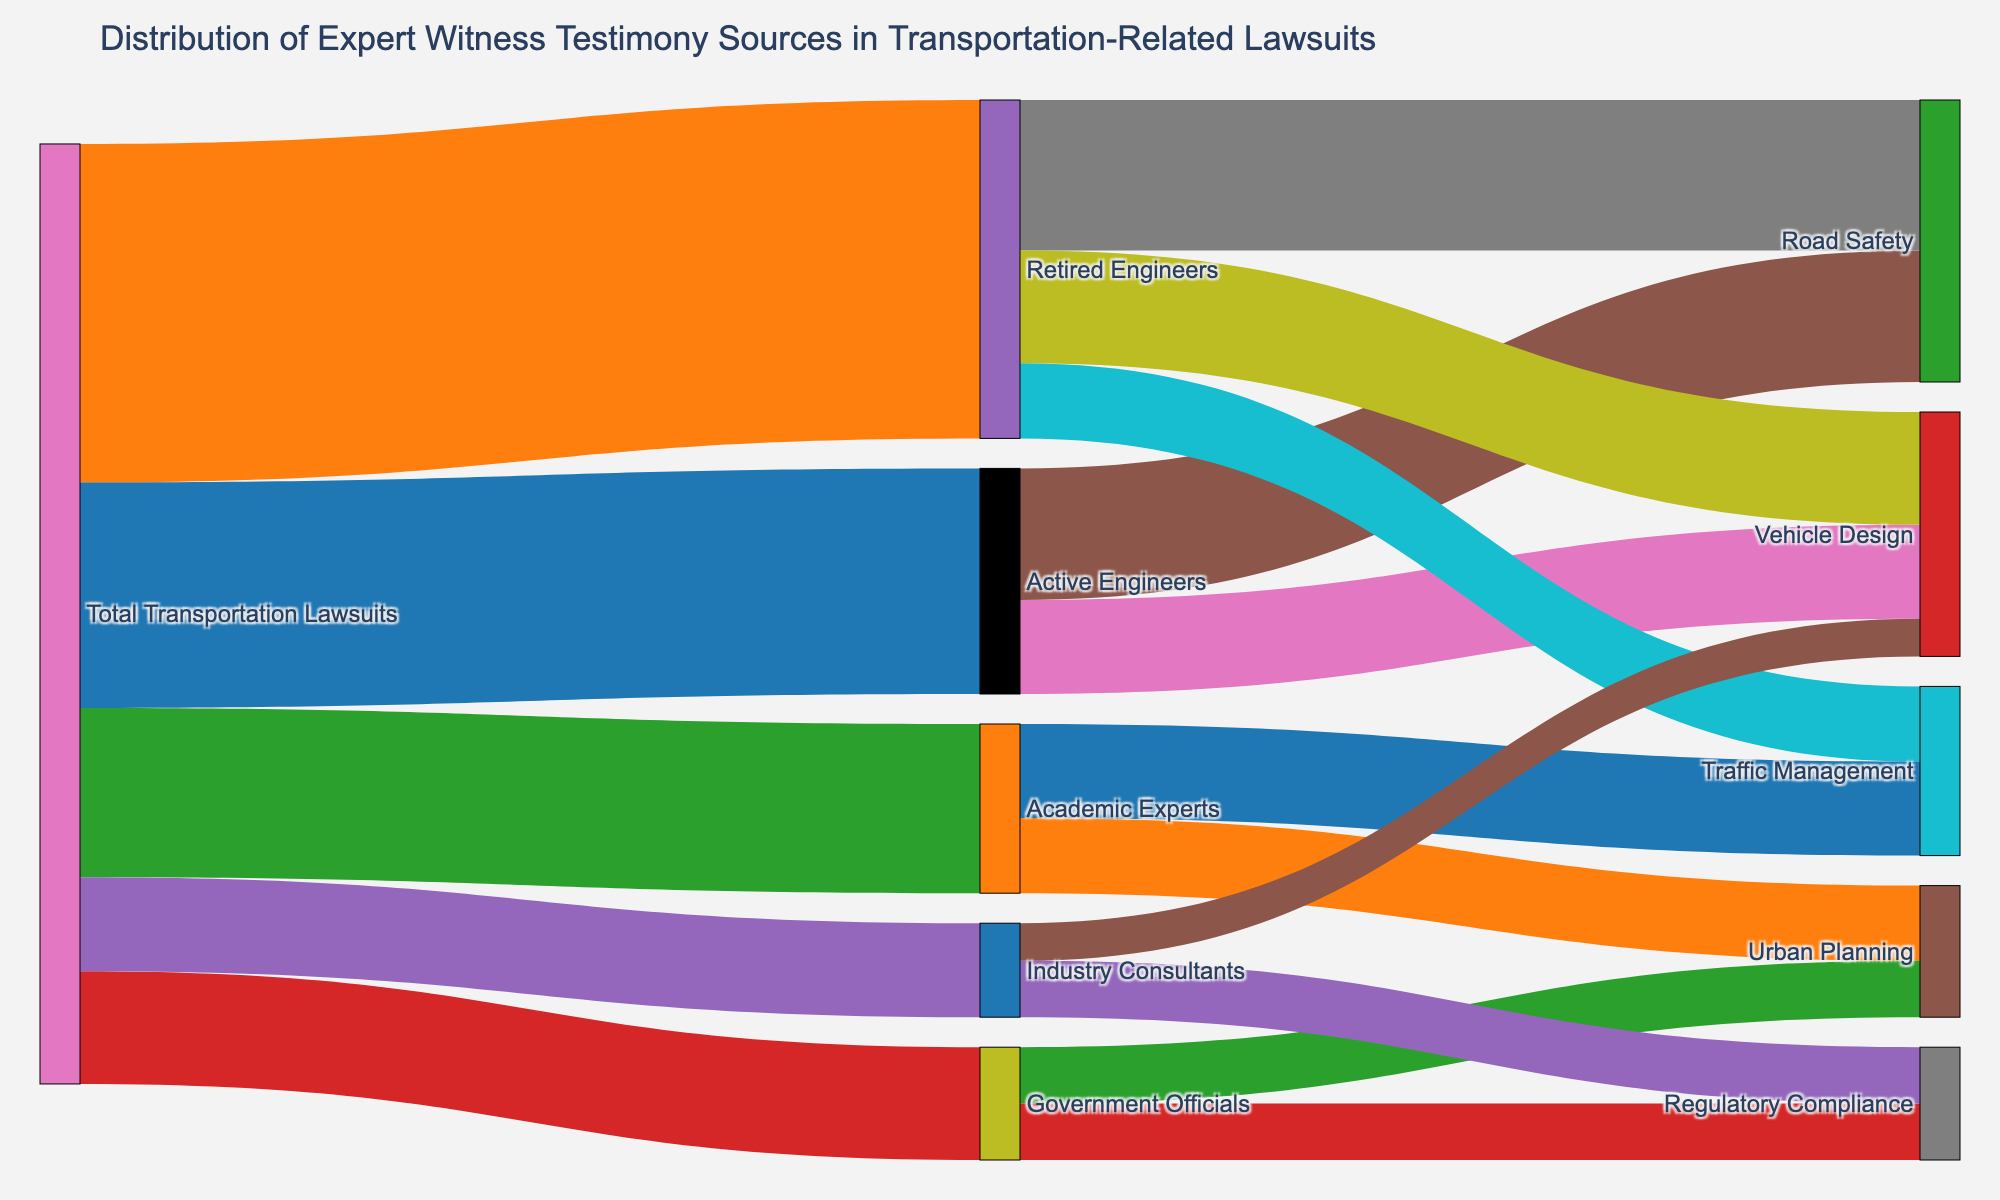what is the title of the plot? The title of the plot is located at the top of the Sankey diagram. The title text reads "Distribution of Expert Witness Testimony Sources in Transportation-Related Lawsuits".
Answer: Distribution of Expert Witness Testimony Sources in Transportation-Related Lawsuits Which group contributed the most expert witness testimony in total transportation lawsuits? By looking at the width of the links, the Retired Engineers group has the largest width, indicating it contributed the most testimony in total transportation lawsuits with a value of 180.
Answer: Retired Engineers How many different testimony areas are covered by Active Engineers? By examining the links coming out of the Active Engineers node, we see three branches leading to Road Safety, Vehicle Design, and Traffic Management, indicating Active Engineers cover three testimony areas.
Answer: Three Which two testimony areas do Retired Engineers cover? Looking at the links from Retired Engineers, we see connections to Road Safety, Vehicle Design, and Traffic Management. Thus, Retired Engineers cover these three areas.
Answer: Road Safety, Vehicle Design, Traffic Management How many testimonies are provided by Government Officials for Urban Planning? Checking the link from Government Officials to Urban Planning, the value is indicated as 30.
Answer: 30 What is the total number of expert testimonies related to Vehicle Design from all sources? Adding the contributions from Active Engineers (50), Retired Engineers (60), and Industry Consultants (20) linked to Vehicle Design, the total is 50 + 60 + 20 = 130.
Answer: 130 Compare the number of testimonies for Road Safety and Regulatory Compliance from Active Engineers and Retired Engineers. Which one is greater? Summing the testimonies for Road Safety (Active Engineers: 70, Retired Engineers: 80) yields 70 + 80 = 150. For Regulatory Compliance (Government Officials: 30, Industry Consultants: 30), the total is 30 + 30 = 60. 150 is greater than 60.
Answer: Road Safety What percentage of total testimonies in the diagram comes from Academic Experts? The total number of testimonies is the sum of all values in the 'value' column: 120 + 180 + 90 + 60 + 50 = 500. Academic Experts contributed 90 testimonies. The percentage is (90/500) * 100 = 18%.
Answer: 18% Which group contributed more to Road Safety: Active Engineers or Retired Engineers? By comparing the values for Road Safety from Active Engineers (70) and Retired Engineers (80), we see that Retired Engineers contributed more.
Answer: Retired Engineers 